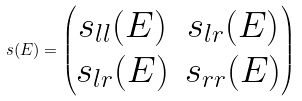<formula> <loc_0><loc_0><loc_500><loc_500>s ( E ) = \left ( \begin{matrix} s _ { l l } ( E ) & s _ { l r } ( E ) \\ s _ { l r } ( E ) & s _ { r r } ( E ) \end{matrix} \right )</formula> 